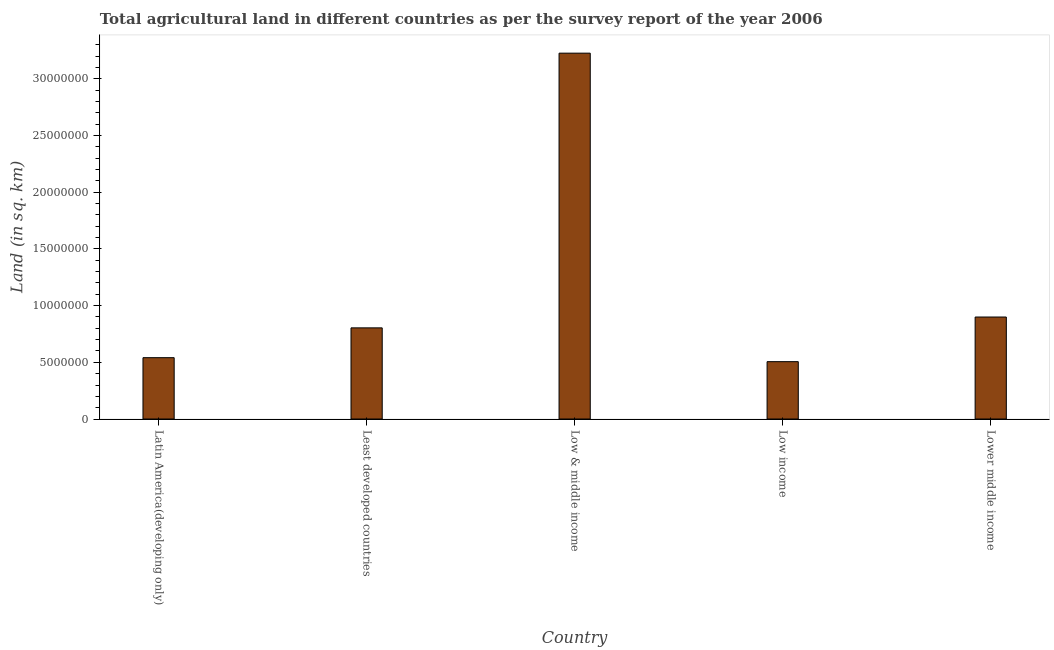Does the graph contain grids?
Provide a short and direct response. No. What is the title of the graph?
Keep it short and to the point. Total agricultural land in different countries as per the survey report of the year 2006. What is the label or title of the Y-axis?
Make the answer very short. Land (in sq. km). What is the agricultural land in Latin America(developing only)?
Offer a terse response. 5.41e+06. Across all countries, what is the maximum agricultural land?
Your answer should be very brief. 3.23e+07. Across all countries, what is the minimum agricultural land?
Make the answer very short. 5.06e+06. What is the sum of the agricultural land?
Make the answer very short. 5.98e+07. What is the difference between the agricultural land in Low income and Lower middle income?
Offer a terse response. -3.94e+06. What is the average agricultural land per country?
Provide a short and direct response. 1.20e+07. What is the median agricultural land?
Your response must be concise. 8.04e+06. What is the ratio of the agricultural land in Low & middle income to that in Low income?
Ensure brevity in your answer.  6.38. What is the difference between the highest and the second highest agricultural land?
Your response must be concise. 2.33e+07. What is the difference between the highest and the lowest agricultural land?
Your answer should be compact. 2.72e+07. In how many countries, is the agricultural land greater than the average agricultural land taken over all countries?
Ensure brevity in your answer.  1. Are all the bars in the graph horizontal?
Ensure brevity in your answer.  No. What is the difference between two consecutive major ticks on the Y-axis?
Your answer should be very brief. 5.00e+06. Are the values on the major ticks of Y-axis written in scientific E-notation?
Offer a very short reply. No. What is the Land (in sq. km) in Latin America(developing only)?
Provide a succinct answer. 5.41e+06. What is the Land (in sq. km) of Least developed countries?
Offer a terse response. 8.04e+06. What is the Land (in sq. km) in Low & middle income?
Keep it short and to the point. 3.23e+07. What is the Land (in sq. km) of Low income?
Offer a very short reply. 5.06e+06. What is the Land (in sq. km) in Lower middle income?
Provide a succinct answer. 9.00e+06. What is the difference between the Land (in sq. km) in Latin America(developing only) and Least developed countries?
Provide a succinct answer. -2.63e+06. What is the difference between the Land (in sq. km) in Latin America(developing only) and Low & middle income?
Your answer should be very brief. -2.69e+07. What is the difference between the Land (in sq. km) in Latin America(developing only) and Low income?
Provide a succinct answer. 3.51e+05. What is the difference between the Land (in sq. km) in Latin America(developing only) and Lower middle income?
Your answer should be very brief. -3.59e+06. What is the difference between the Land (in sq. km) in Least developed countries and Low & middle income?
Give a very brief answer. -2.42e+07. What is the difference between the Land (in sq. km) in Least developed countries and Low income?
Provide a succinct answer. 2.98e+06. What is the difference between the Land (in sq. km) in Least developed countries and Lower middle income?
Your response must be concise. -9.56e+05. What is the difference between the Land (in sq. km) in Low & middle income and Low income?
Ensure brevity in your answer.  2.72e+07. What is the difference between the Land (in sq. km) in Low & middle income and Lower middle income?
Keep it short and to the point. 2.33e+07. What is the difference between the Land (in sq. km) in Low income and Lower middle income?
Your answer should be very brief. -3.94e+06. What is the ratio of the Land (in sq. km) in Latin America(developing only) to that in Least developed countries?
Give a very brief answer. 0.67. What is the ratio of the Land (in sq. km) in Latin America(developing only) to that in Low & middle income?
Offer a terse response. 0.17. What is the ratio of the Land (in sq. km) in Latin America(developing only) to that in Low income?
Offer a terse response. 1.07. What is the ratio of the Land (in sq. km) in Latin America(developing only) to that in Lower middle income?
Provide a succinct answer. 0.6. What is the ratio of the Land (in sq. km) in Least developed countries to that in Low & middle income?
Provide a short and direct response. 0.25. What is the ratio of the Land (in sq. km) in Least developed countries to that in Low income?
Give a very brief answer. 1.59. What is the ratio of the Land (in sq. km) in Least developed countries to that in Lower middle income?
Offer a very short reply. 0.89. What is the ratio of the Land (in sq. km) in Low & middle income to that in Low income?
Keep it short and to the point. 6.38. What is the ratio of the Land (in sq. km) in Low & middle income to that in Lower middle income?
Make the answer very short. 3.59. What is the ratio of the Land (in sq. km) in Low income to that in Lower middle income?
Make the answer very short. 0.56. 